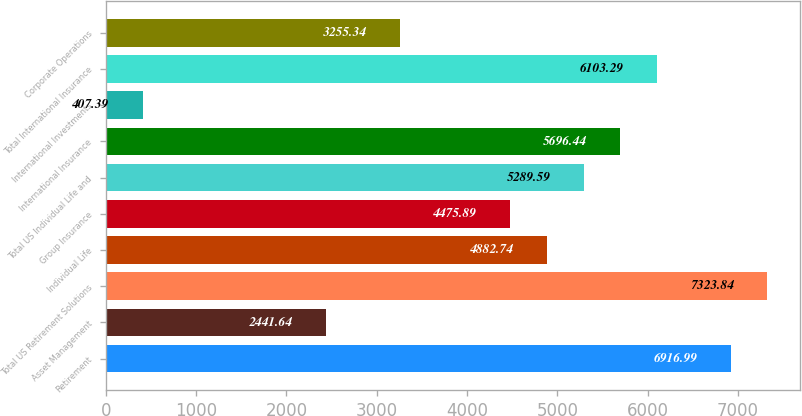<chart> <loc_0><loc_0><loc_500><loc_500><bar_chart><fcel>Retirement<fcel>Asset Management<fcel>Total US Retirement Solutions<fcel>Individual Life<fcel>Group Insurance<fcel>Total US Individual Life and<fcel>International Insurance<fcel>International Investments<fcel>Total International Insurance<fcel>Corporate Operations<nl><fcel>6916.99<fcel>2441.64<fcel>7323.84<fcel>4882.74<fcel>4475.89<fcel>5289.59<fcel>5696.44<fcel>407.39<fcel>6103.29<fcel>3255.34<nl></chart> 